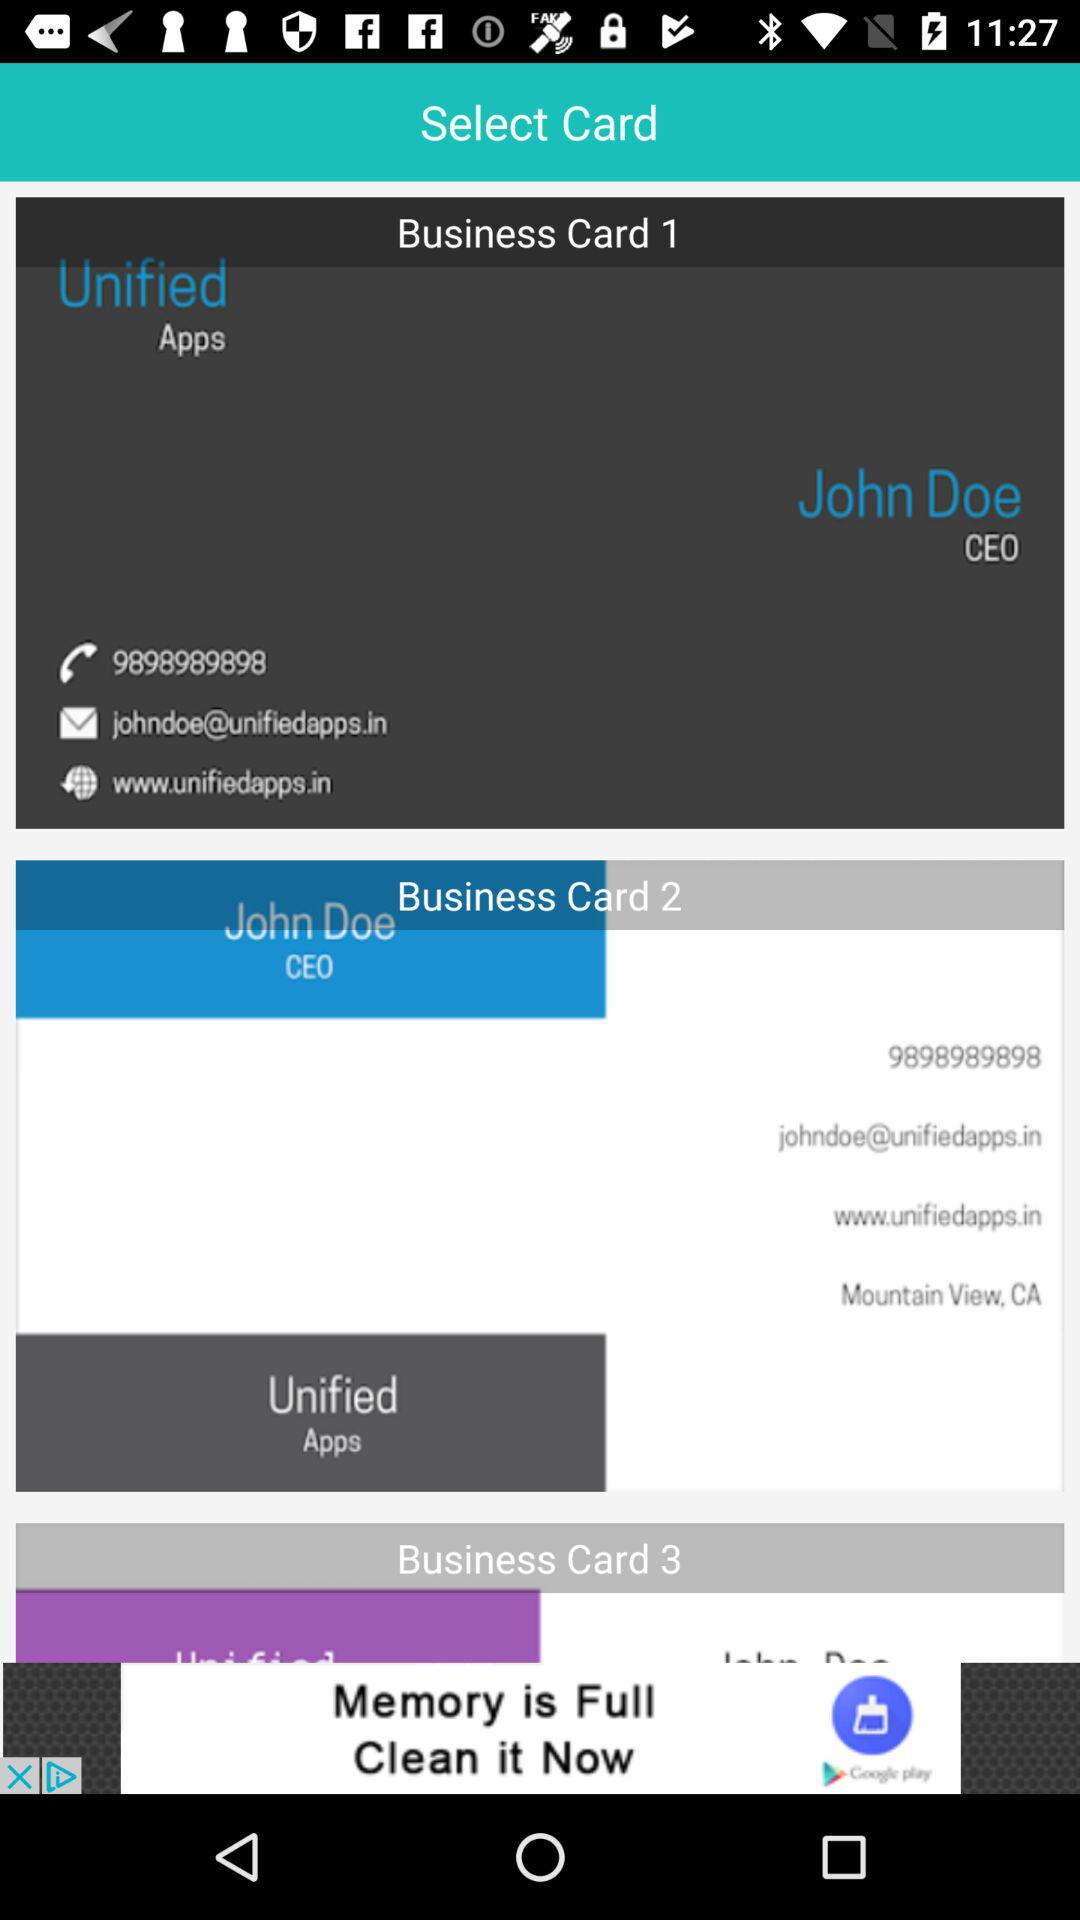What's the URL? The URL is www.unifiedapps.in. 